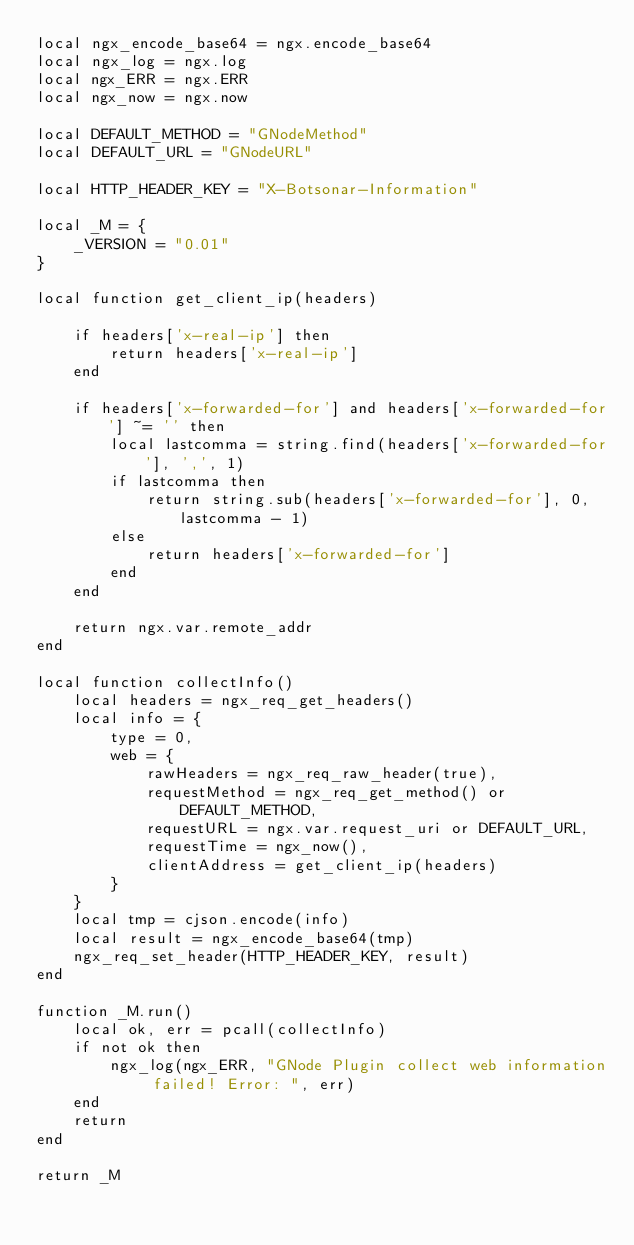<code> <loc_0><loc_0><loc_500><loc_500><_Lua_>local ngx_encode_base64 = ngx.encode_base64
local ngx_log = ngx.log
local ngx_ERR = ngx.ERR
local ngx_now = ngx.now

local DEFAULT_METHOD = "GNodeMethod"
local DEFAULT_URL = "GNodeURL"

local HTTP_HEADER_KEY = "X-Botsonar-Information"

local _M = {
    _VERSION = "0.01"
}

local function get_client_ip(headers)

    if headers['x-real-ip'] then
        return headers['x-real-ip']
    end

    if headers['x-forwarded-for'] and headers['x-forwarded-for'] ~= '' then
        local lastcomma = string.find(headers['x-forwarded-for'], ',', 1)
        if lastcomma then
            return string.sub(headers['x-forwarded-for'], 0, lastcomma - 1)
        else
            return headers['x-forwarded-for']
        end
    end

    return ngx.var.remote_addr
end

local function collectInfo()
    local headers = ngx_req_get_headers()
    local info = {
        type = 0,
        web = {
            rawHeaders = ngx_req_raw_header(true),
            requestMethod = ngx_req_get_method() or DEFAULT_METHOD,
            requestURL = ngx.var.request_uri or DEFAULT_URL,
            requestTime = ngx_now(),
            clientAddress = get_client_ip(headers)
        }
    }
    local tmp = cjson.encode(info)
    local result = ngx_encode_base64(tmp)
    ngx_req_set_header(HTTP_HEADER_KEY, result)
end

function _M.run()
    local ok, err = pcall(collectInfo)
    if not ok then
        ngx_log(ngx_ERR, "GNode Plugin collect web information failed! Error: ", err)
    end
    return
end

return _M</code> 